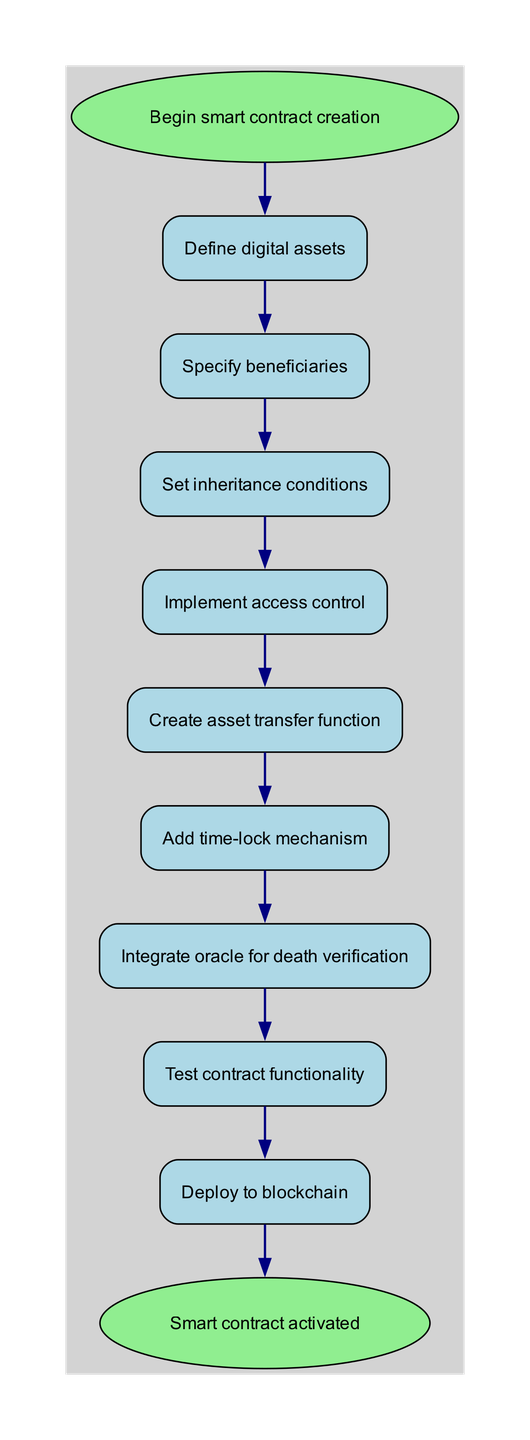What is the first step in the process? The process starts with the "Begin smart contract creation" node and immediately proceeds to "Define digital assets," which is the first step shown in the diagram.
Answer: Define digital assets How many total steps are in the flow chart? By counting all the steps listed between the starting point and the end node, including the final activation of the smart contract, we find that there are nine steps in total.
Answer: 9 What is the last action before the contract is deployed? The last action before deployment is "Test contract functionality," which directly precedes the "Deploy to blockchain" step in the flow chart.
Answer: Test contract functionality Which step directly follows "Integrate oracle for death verification"? After "Integrate oracle for death verification," the next step is "Test contract functionality," as shown by the flow connection from one step to the next.
Answer: Test contract functionality What color represents the end nodes? The end nodes in the diagram are colored light green, indicating the start and end of the flow chart for the smart contract creation process.
Answer: Light green What is the purpose of adding a time-lock mechanism? The addition of a time-lock mechanism is intended to control when assets can be transferred, ensuring that beneficiaries must wait a specified period before accessing the assets, according to inheritance conditions.
Answer: Control asset transfer timing How does access control fit into the process? Access control is implemented after specifying the beneficiaries and setting the inheritance conditions, ensuring that only designated parties can execute the asset transfer function.
Answer: After beneficiaries and conditions Which step comes directly before "Deploy to blockchain"? The step "Test contract functionality" comes directly before the "Deploy to blockchain" step, as indicated by the flow from one step to the next in the diagram.
Answer: Test contract functionality What condition must be set before creating an asset transfer function? Before creating an asset transfer function, the inheritance conditions must be set, ensuring that the transfer logic adheres to the defined rules for asset distribution.
Answer: Set inheritance conditions 